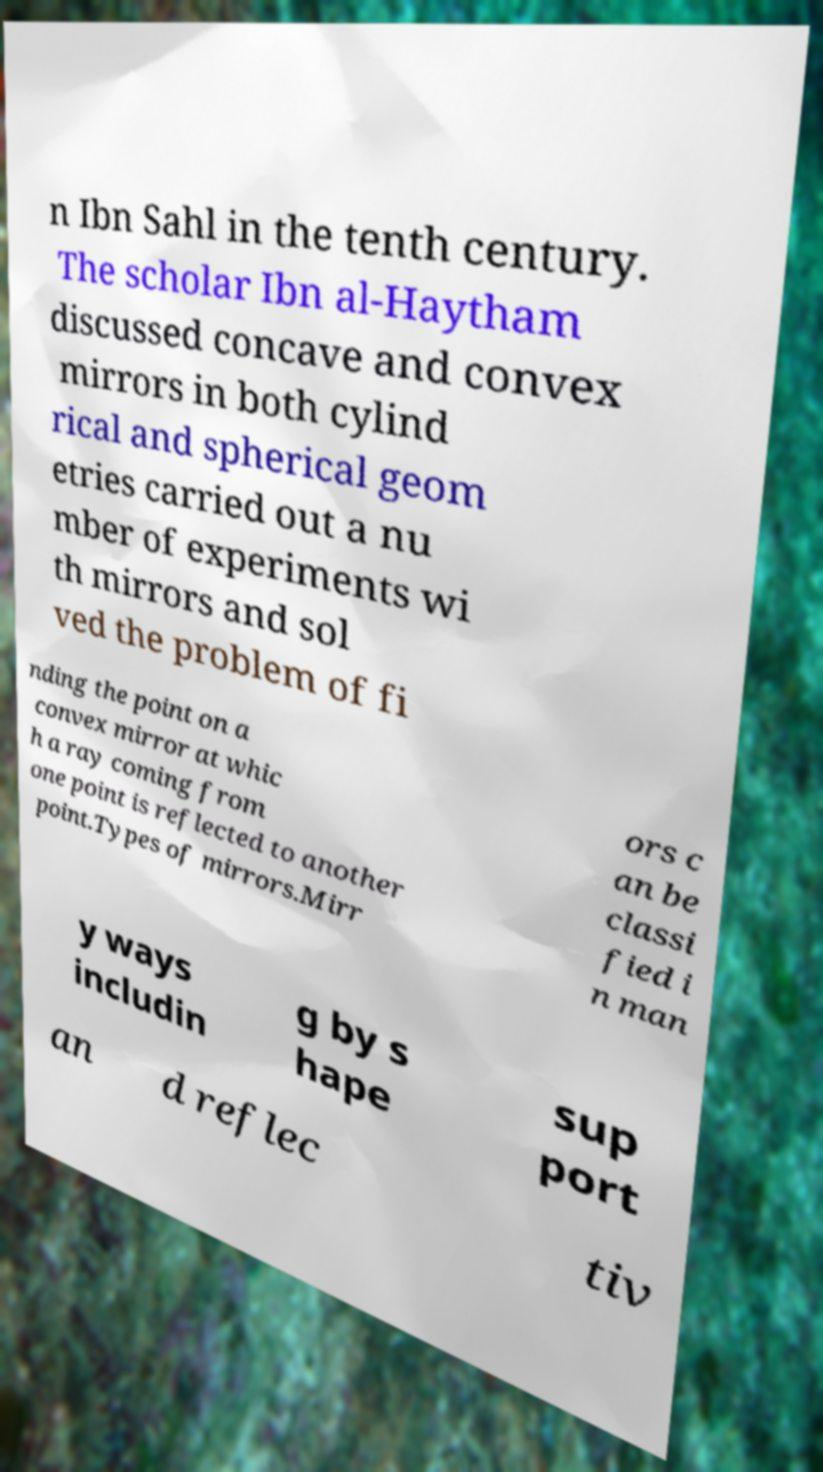Could you extract and type out the text from this image? n Ibn Sahl in the tenth century. The scholar Ibn al-Haytham discussed concave and convex mirrors in both cylind rical and spherical geom etries carried out a nu mber of experiments wi th mirrors and sol ved the problem of fi nding the point on a convex mirror at whic h a ray coming from one point is reflected to another point.Types of mirrors.Mirr ors c an be classi fied i n man y ways includin g by s hape sup port an d reflec tiv 